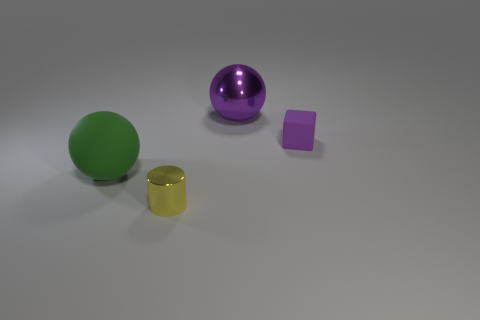What number of things are balls that are to the right of the tiny shiny cylinder or tiny yellow metallic things?
Make the answer very short. 2. Is the number of green matte things less than the number of small objects?
Provide a succinct answer. Yes. There is a big green object that is the same material as the tiny purple cube; what shape is it?
Your response must be concise. Sphere. Are there any things to the right of the small yellow metal thing?
Make the answer very short. Yes. Are there fewer big purple metallic spheres to the right of the tiny rubber thing than green matte objects?
Your response must be concise. Yes. What is the material of the purple block?
Offer a very short reply. Rubber. The large rubber sphere has what color?
Provide a short and direct response. Green. What color is the object that is both right of the green ball and left of the large metal sphere?
Your answer should be compact. Yellow. Are there any other things that are the same material as the purple block?
Give a very brief answer. Yes. Does the tiny cube have the same material as the sphere that is behind the green matte ball?
Give a very brief answer. No. 